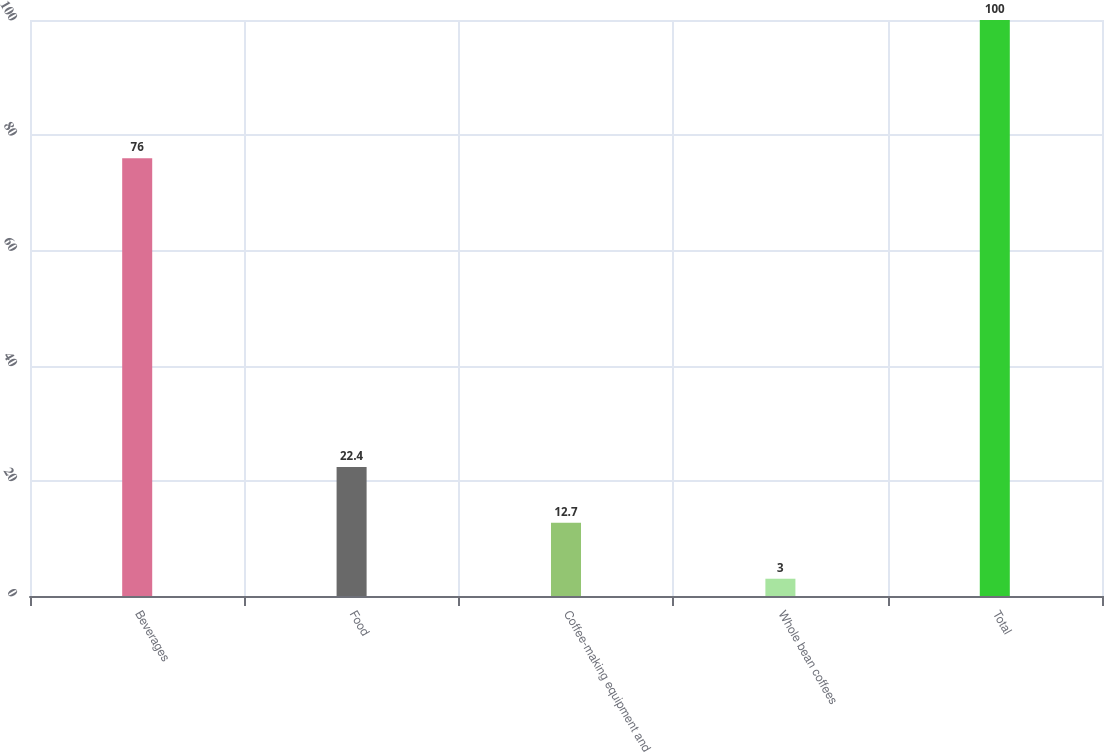Convert chart to OTSL. <chart><loc_0><loc_0><loc_500><loc_500><bar_chart><fcel>Beverages<fcel>Food<fcel>Coffee-making equipment and<fcel>Whole bean coffees<fcel>Total<nl><fcel>76<fcel>22.4<fcel>12.7<fcel>3<fcel>100<nl></chart> 